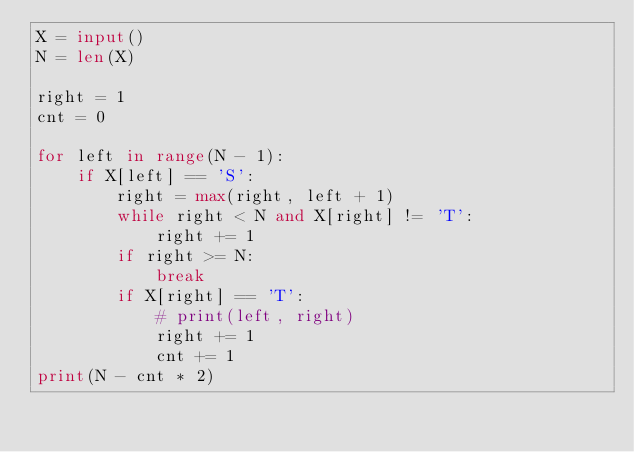Convert code to text. <code><loc_0><loc_0><loc_500><loc_500><_Python_>X = input()
N = len(X)

right = 1
cnt = 0

for left in range(N - 1):
    if X[left] == 'S':
        right = max(right, left + 1)
        while right < N and X[right] != 'T':
            right += 1
        if right >= N:
            break
        if X[right] == 'T':
            # print(left, right)
            right += 1
            cnt += 1
print(N - cnt * 2)</code> 